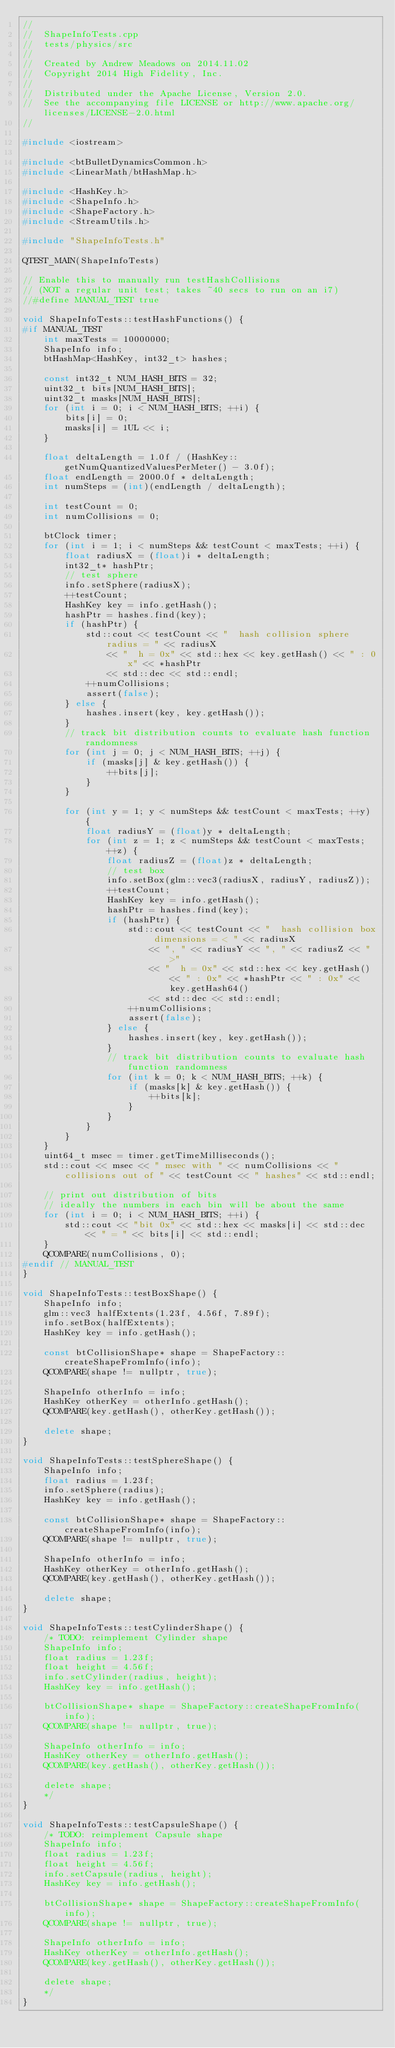<code> <loc_0><loc_0><loc_500><loc_500><_C++_>//
//  ShapeInfoTests.cpp
//  tests/physics/src
//
//  Created by Andrew Meadows on 2014.11.02
//  Copyright 2014 High Fidelity, Inc.
//
//  Distributed under the Apache License, Version 2.0.
//  See the accompanying file LICENSE or http://www.apache.org/licenses/LICENSE-2.0.html
//

#include <iostream>

#include <btBulletDynamicsCommon.h>
#include <LinearMath/btHashMap.h>

#include <HashKey.h>
#include <ShapeInfo.h>
#include <ShapeFactory.h>
#include <StreamUtils.h>

#include "ShapeInfoTests.h"

QTEST_MAIN(ShapeInfoTests)

// Enable this to manually run testHashCollisions
// (NOT a regular unit test; takes ~40 secs to run on an i7)
//#define MANUAL_TEST true

void ShapeInfoTests::testHashFunctions() {
#if MANUAL_TEST
    int maxTests = 10000000;
    ShapeInfo info;
    btHashMap<HashKey, int32_t> hashes;

    const int32_t NUM_HASH_BITS = 32;
    uint32_t bits[NUM_HASH_BITS];
    uint32_t masks[NUM_HASH_BITS];
    for (int i = 0; i < NUM_HASH_BITS; ++i) {
        bits[i] = 0;
        masks[i] = 1UL << i;
    }

    float deltaLength = 1.0f / (HashKey::getNumQuantizedValuesPerMeter() - 3.0f);
    float endLength = 2000.0f * deltaLength;
    int numSteps = (int)(endLength / deltaLength);

    int testCount = 0;
    int numCollisions = 0;

    btClock timer;
    for (int i = 1; i < numSteps && testCount < maxTests; ++i) {
        float radiusX = (float)i * deltaLength;
        int32_t* hashPtr;
        // test sphere
        info.setSphere(radiusX);
        ++testCount;
        HashKey key = info.getHash();
        hashPtr = hashes.find(key);
        if (hashPtr) {
            std::cout << testCount << "  hash collision sphere radius = " << radiusX
                << "  h = 0x" << std::hex << key.getHash() << " : 0x" << *hashPtr
                << std::dec << std::endl;
            ++numCollisions;
            assert(false);
        } else {
            hashes.insert(key, key.getHash());
        }
        // track bit distribution counts to evaluate hash function randomness
        for (int j = 0; j < NUM_HASH_BITS; ++j) {
            if (masks[j] & key.getHash()) {
                ++bits[j];
            }
        }

        for (int y = 1; y < numSteps && testCount < maxTests; ++y) {
            float radiusY = (float)y * deltaLength;
            for (int z = 1; z < numSteps && testCount < maxTests; ++z) {
                float radiusZ = (float)z * deltaLength;
                // test box
                info.setBox(glm::vec3(radiusX, radiusY, radiusZ));
                ++testCount;
                HashKey key = info.getHash();
                hashPtr = hashes.find(key);
                if (hashPtr) {
                    std::cout << testCount << "  hash collision box dimensions = < " << radiusX
                        << ", " << radiusY << ", " << radiusZ << " >"
                        << "  h = 0x" << std::hex << key.getHash() << " : 0x" << *hashPtr << " : 0x" << key.getHash64()
                        << std::dec << std::endl;
                    ++numCollisions;
                    assert(false);
                } else {
                    hashes.insert(key, key.getHash());
                }
                // track bit distribution counts to evaluate hash function randomness
                for (int k = 0; k < NUM_HASH_BITS; ++k) {
                    if (masks[k] & key.getHash()) {
                        ++bits[k];
                    }
                }
            }
        }
    }
    uint64_t msec = timer.getTimeMilliseconds();
    std::cout << msec << " msec with " << numCollisions << " collisions out of " << testCount << " hashes" << std::endl;

    // print out distribution of bits
    // ideally the numbers in each bin will be about the same
    for (int i = 0; i < NUM_HASH_BITS; ++i) {
        std::cout << "bit 0x" << std::hex << masks[i] << std::dec << " = " << bits[i] << std::endl;
    }
    QCOMPARE(numCollisions, 0);
#endif // MANUAL_TEST
}

void ShapeInfoTests::testBoxShape() {
    ShapeInfo info;
    glm::vec3 halfExtents(1.23f, 4.56f, 7.89f);
    info.setBox(halfExtents);
    HashKey key = info.getHash();

    const btCollisionShape* shape = ShapeFactory::createShapeFromInfo(info);
    QCOMPARE(shape != nullptr, true);

    ShapeInfo otherInfo = info;
    HashKey otherKey = otherInfo.getHash();
    QCOMPARE(key.getHash(), otherKey.getHash());

    delete shape;
}

void ShapeInfoTests::testSphereShape() {
    ShapeInfo info;
    float radius = 1.23f;
    info.setSphere(radius);
    HashKey key = info.getHash();

    const btCollisionShape* shape = ShapeFactory::createShapeFromInfo(info);
    QCOMPARE(shape != nullptr, true);

    ShapeInfo otherInfo = info;
    HashKey otherKey = otherInfo.getHash();
    QCOMPARE(key.getHash(), otherKey.getHash());

    delete shape;
}

void ShapeInfoTests::testCylinderShape() {
    /* TODO: reimplement Cylinder shape
    ShapeInfo info;
    float radius = 1.23f;
    float height = 4.56f;
    info.setCylinder(radius, height);
    HashKey key = info.getHash();

    btCollisionShape* shape = ShapeFactory::createShapeFromInfo(info);
    QCOMPARE(shape != nullptr, true);

    ShapeInfo otherInfo = info;
    HashKey otherKey = otherInfo.getHash();
    QCOMPARE(key.getHash(), otherKey.getHash());

    delete shape;
    */
}

void ShapeInfoTests::testCapsuleShape() {
    /* TODO: reimplement Capsule shape
    ShapeInfo info;
    float radius = 1.23f;
    float height = 4.56f;
    info.setCapsule(radius, height);
    HashKey key = info.getHash();

    btCollisionShape* shape = ShapeFactory::createShapeFromInfo(info);
    QCOMPARE(shape != nullptr, true);

    ShapeInfo otherInfo = info;
    HashKey otherKey = otherInfo.getHash();
    QCOMPARE(key.getHash(), otherKey.getHash());

    delete shape;
    */
}

</code> 